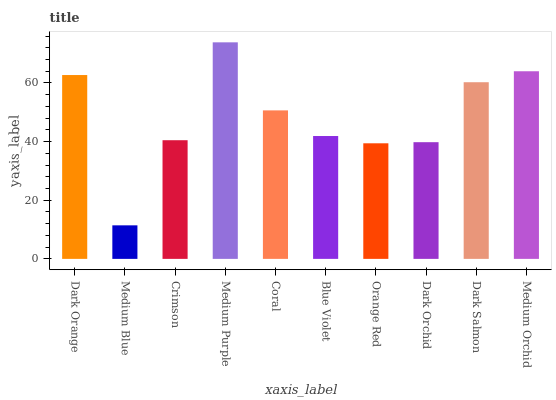Is Medium Blue the minimum?
Answer yes or no. Yes. Is Medium Purple the maximum?
Answer yes or no. Yes. Is Crimson the minimum?
Answer yes or no. No. Is Crimson the maximum?
Answer yes or no. No. Is Crimson greater than Medium Blue?
Answer yes or no. Yes. Is Medium Blue less than Crimson?
Answer yes or no. Yes. Is Medium Blue greater than Crimson?
Answer yes or no. No. Is Crimson less than Medium Blue?
Answer yes or no. No. Is Coral the high median?
Answer yes or no. Yes. Is Blue Violet the low median?
Answer yes or no. Yes. Is Dark Orchid the high median?
Answer yes or no. No. Is Crimson the low median?
Answer yes or no. No. 